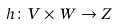<formula> <loc_0><loc_0><loc_500><loc_500>h \colon V \times W \to Z</formula> 